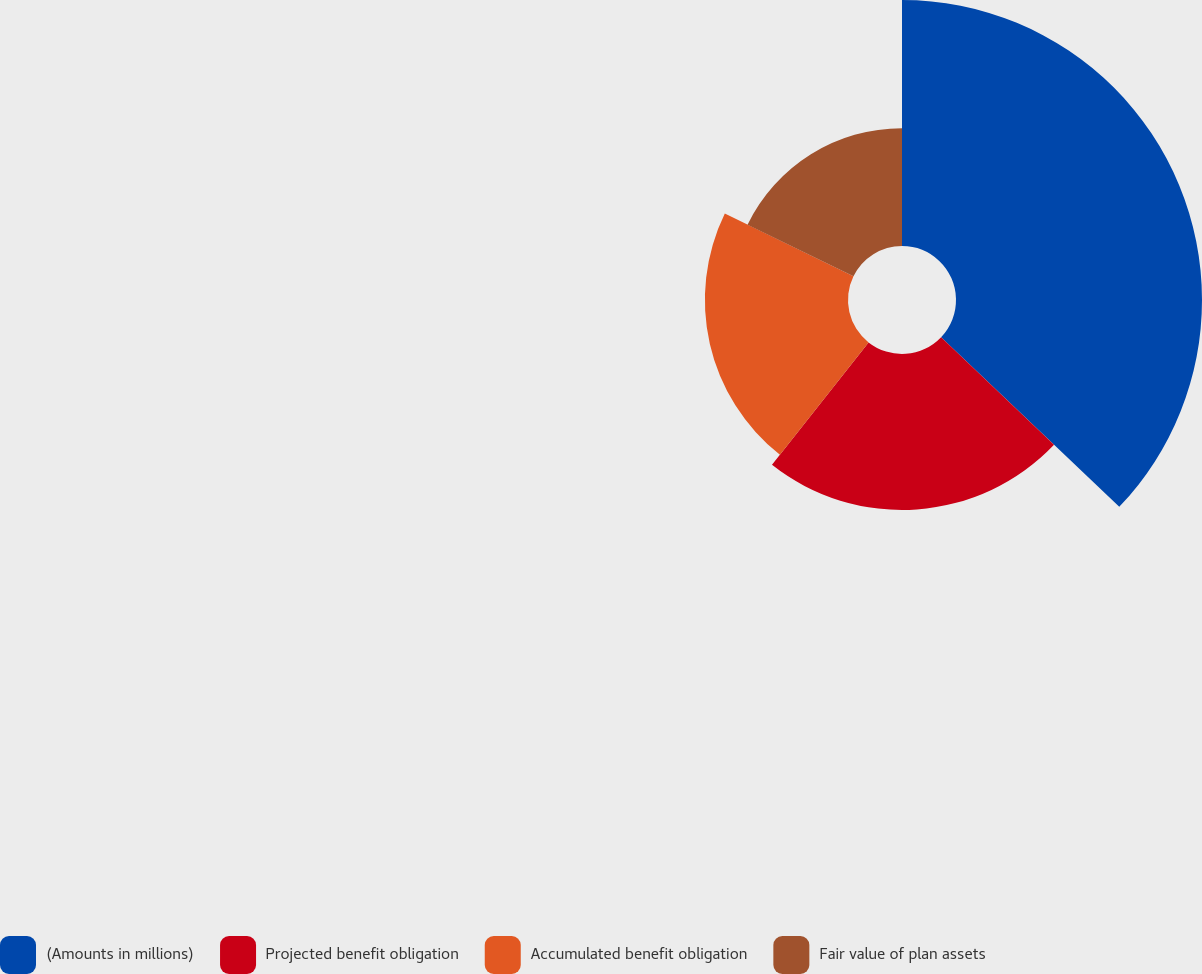<chart> <loc_0><loc_0><loc_500><loc_500><pie_chart><fcel>(Amounts in millions)<fcel>Projected benefit obligation<fcel>Accumulated benefit obligation<fcel>Fair value of plan assets<nl><fcel>37.11%<fcel>23.52%<fcel>21.59%<fcel>17.78%<nl></chart> 